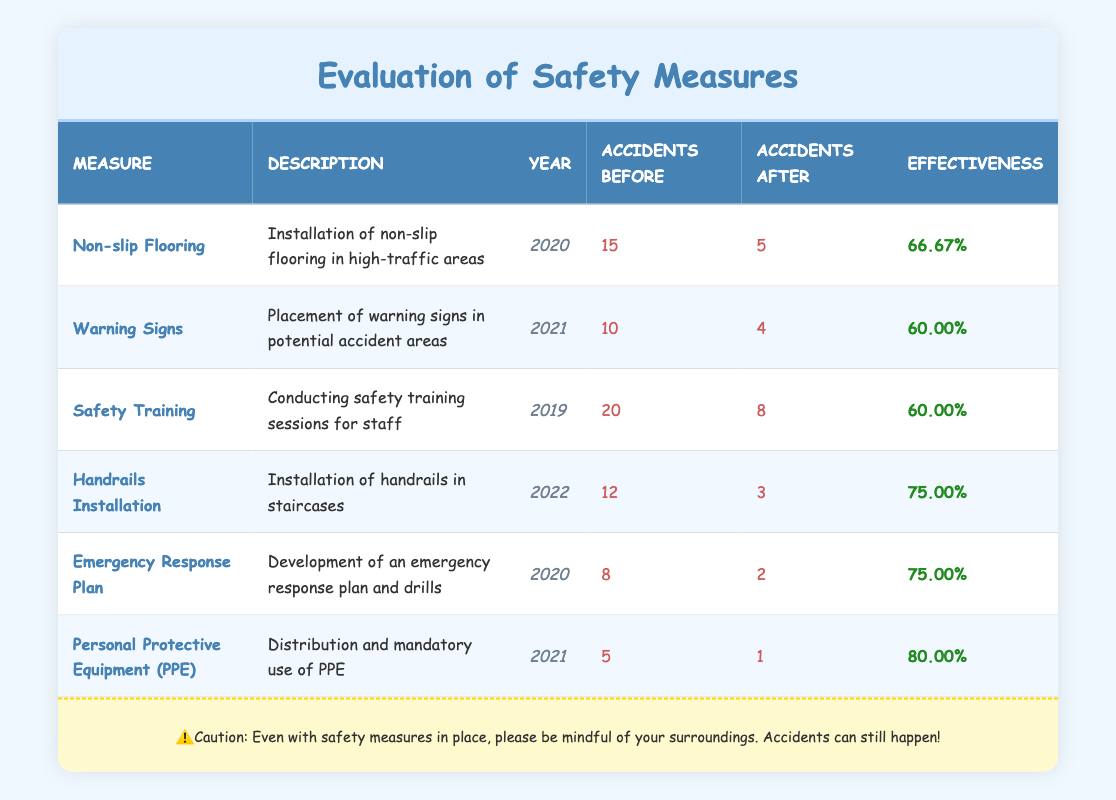What safety measure had the highest effectiveness percentage? By looking at the "Effectiveness" column, the measure with the highest percentage is "Personal Protective Equipment (PPE)" at 80.00%.
Answer: Personal Protective Equipment (PPE) How many accidents were recorded before the implementation of the "Warning Signs"? The table shows that there were 10 accidents recorded before the implementation of "Warning Signs".
Answer: 10 What is the total number of accidents before all the safety measures were implemented? To find the total, we sum the "Accidents Before" column: 15 + 10 + 20 + 12 + 8 + 5 = 70. The total number of accidents before implementation is 70.
Answer: 70 Which measure was implemented in the year 2022? The table indicates that "Handrails Installation" was the only measure implemented in the year 2022.
Answer: Handrails Installation Did the implementation of "Emergency Response Plan" reduce the number of accidents by more than half? The number of accidents before the implementation was 8, and after was 2. To find out if this is more than half, we calculate: 8 - 2 = 6, which is more than half of 8.
Answer: Yes What is the average effectiveness percentage of all the measures listed? To find the average, we add the effectiveness percentages (66.67 + 60.00 + 60.00 + 75.00 + 75.00 + 80.00 = 416.67) and divide by the number of measures (6) gives us an average of approximately 69.44%.
Answer: 69.44% Which safety measure had the least number of accidents after implementation? The "Personal Protective Equipment (PPE)" had the least accidents after implementation with just 1 accident recorded.
Answer: Personal Protective Equipment (PPE) Is it true that "Safety Training" had more accidents after implementation compared to "Handrails Installation"? The accidents after "Safety Training" were 8, while for "Handrails Installation" it was 3. Since 8 is greater than 3, the statement is true.
Answer: Yes 